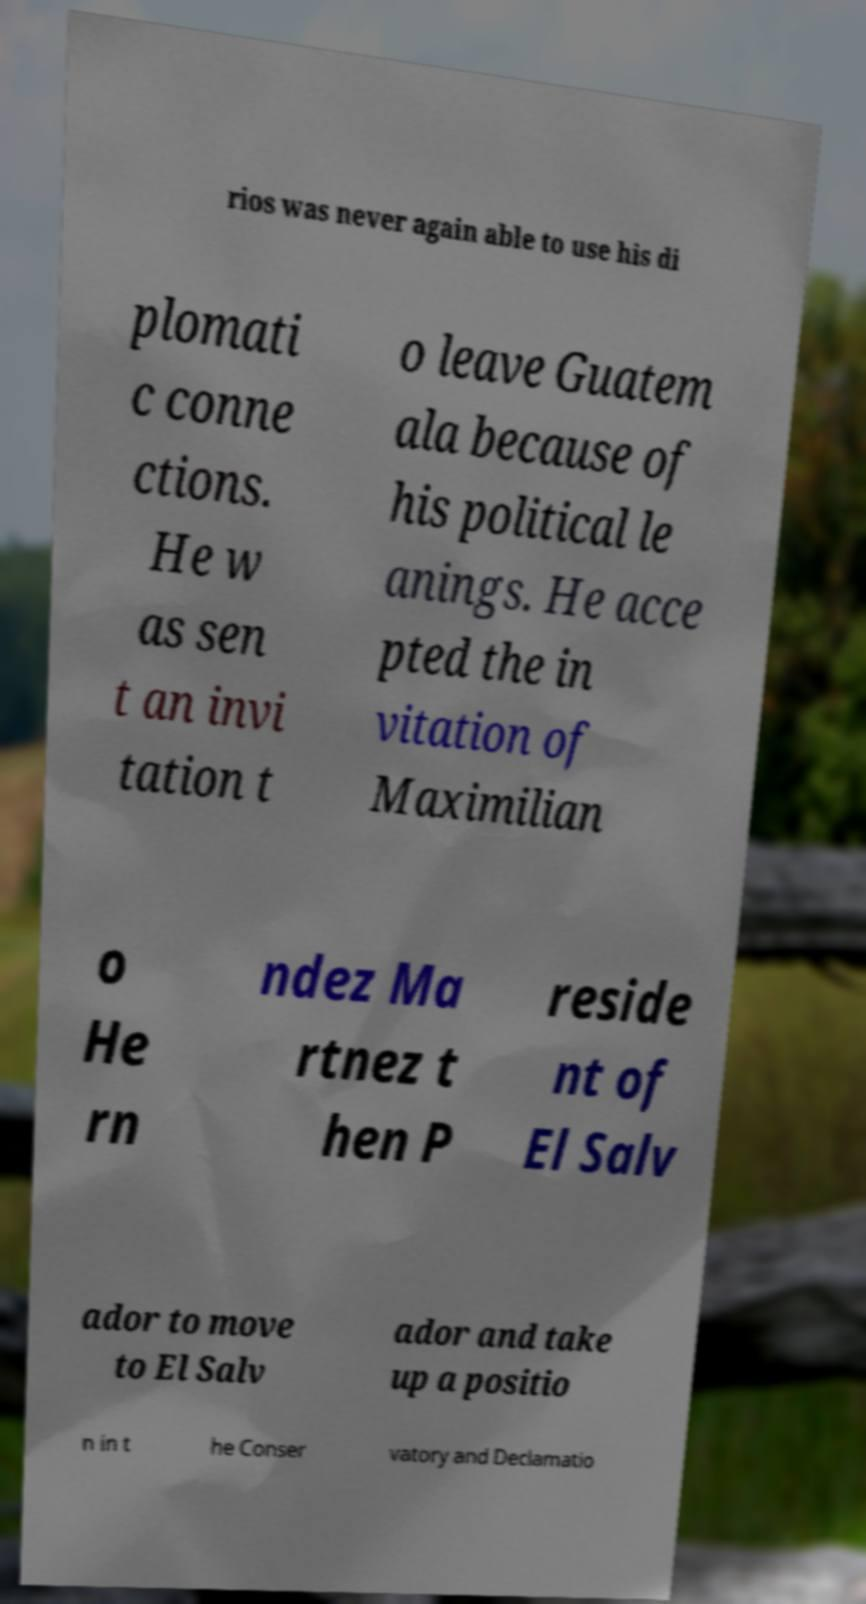Could you extract and type out the text from this image? rios was never again able to use his di plomati c conne ctions. He w as sen t an invi tation t o leave Guatem ala because of his political le anings. He acce pted the in vitation of Maximilian o He rn ndez Ma rtnez t hen P reside nt of El Salv ador to move to El Salv ador and take up a positio n in t he Conser vatory and Declamatio 